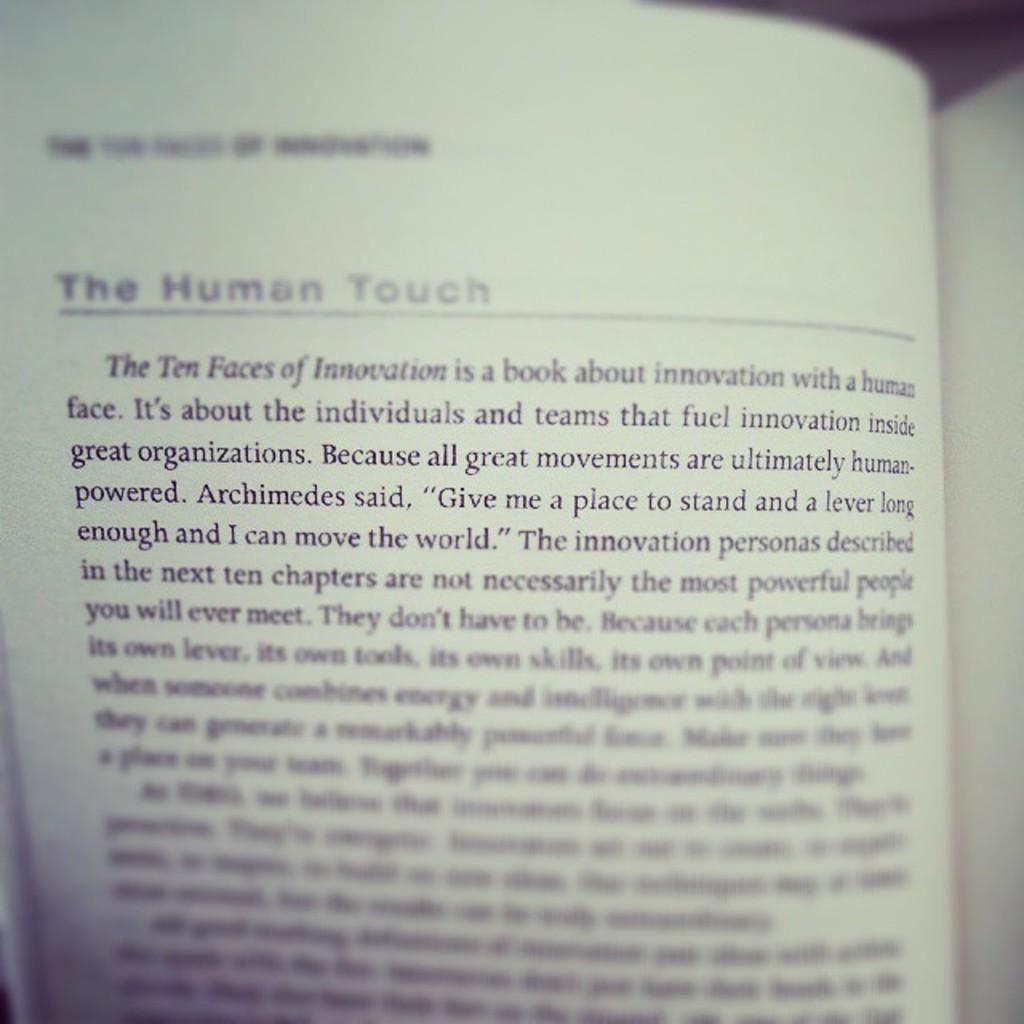<image>
Create a compact narrative representing the image presented. open book and on the left page it has The Human Touch underlined near the top 